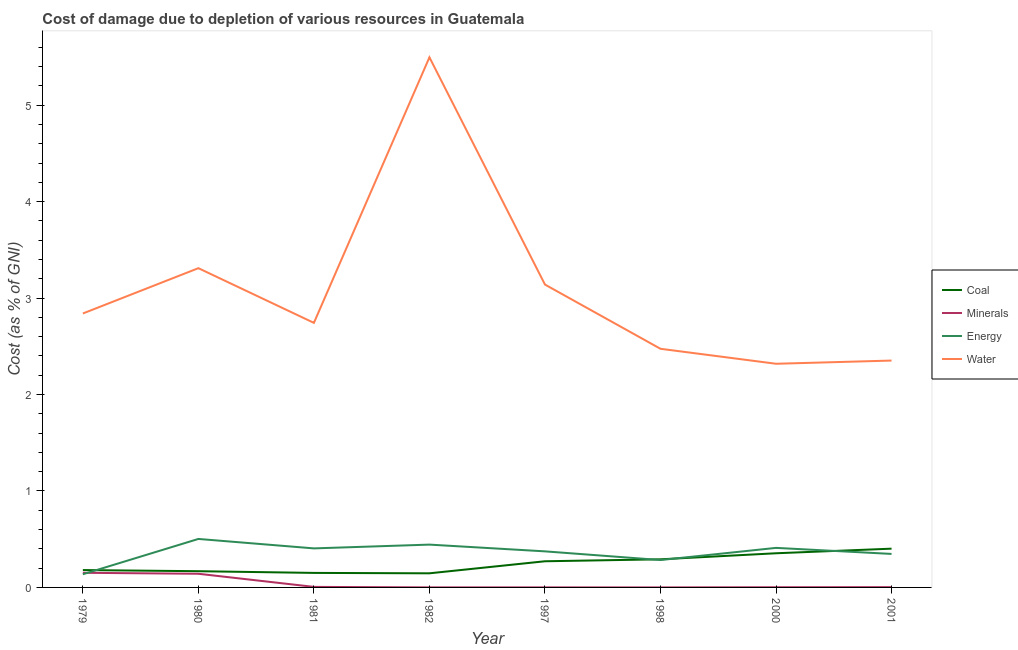How many different coloured lines are there?
Give a very brief answer. 4. Does the line corresponding to cost of damage due to depletion of coal intersect with the line corresponding to cost of damage due to depletion of minerals?
Offer a very short reply. No. Is the number of lines equal to the number of legend labels?
Your answer should be compact. Yes. What is the cost of damage due to depletion of water in 1981?
Provide a succinct answer. 2.74. Across all years, what is the maximum cost of damage due to depletion of minerals?
Provide a short and direct response. 0.15. Across all years, what is the minimum cost of damage due to depletion of water?
Make the answer very short. 2.32. In which year was the cost of damage due to depletion of energy maximum?
Your response must be concise. 1980. What is the total cost of damage due to depletion of minerals in the graph?
Your answer should be compact. 0.31. What is the difference between the cost of damage due to depletion of minerals in 1980 and that in 2001?
Your response must be concise. 0.14. What is the difference between the cost of damage due to depletion of water in 1997 and the cost of damage due to depletion of coal in 1998?
Keep it short and to the point. 2.85. What is the average cost of damage due to depletion of energy per year?
Offer a very short reply. 0.36. In the year 2000, what is the difference between the cost of damage due to depletion of energy and cost of damage due to depletion of water?
Offer a terse response. -1.91. What is the ratio of the cost of damage due to depletion of coal in 1979 to that in 2001?
Provide a short and direct response. 0.45. Is the cost of damage due to depletion of water in 1980 less than that in 2000?
Provide a short and direct response. No. Is the difference between the cost of damage due to depletion of water in 1981 and 2000 greater than the difference between the cost of damage due to depletion of coal in 1981 and 2000?
Your answer should be compact. Yes. What is the difference between the highest and the second highest cost of damage due to depletion of energy?
Provide a short and direct response. 0.06. What is the difference between the highest and the lowest cost of damage due to depletion of energy?
Your response must be concise. 0.37. Is the sum of the cost of damage due to depletion of coal in 1982 and 2001 greater than the maximum cost of damage due to depletion of energy across all years?
Ensure brevity in your answer.  Yes. Is it the case that in every year, the sum of the cost of damage due to depletion of energy and cost of damage due to depletion of minerals is greater than the sum of cost of damage due to depletion of coal and cost of damage due to depletion of water?
Your answer should be compact. No. Is it the case that in every year, the sum of the cost of damage due to depletion of coal and cost of damage due to depletion of minerals is greater than the cost of damage due to depletion of energy?
Give a very brief answer. No. Does the cost of damage due to depletion of coal monotonically increase over the years?
Keep it short and to the point. No. How many years are there in the graph?
Provide a short and direct response. 8. What is the difference between two consecutive major ticks on the Y-axis?
Give a very brief answer. 1. How are the legend labels stacked?
Provide a short and direct response. Vertical. What is the title of the graph?
Offer a terse response. Cost of damage due to depletion of various resources in Guatemala . What is the label or title of the Y-axis?
Offer a terse response. Cost (as % of GNI). What is the Cost (as % of GNI) in Coal in 1979?
Provide a succinct answer. 0.18. What is the Cost (as % of GNI) of Minerals in 1979?
Your answer should be compact. 0.15. What is the Cost (as % of GNI) of Energy in 1979?
Provide a short and direct response. 0.14. What is the Cost (as % of GNI) in Water in 1979?
Your answer should be compact. 2.84. What is the Cost (as % of GNI) in Coal in 1980?
Provide a short and direct response. 0.17. What is the Cost (as % of GNI) of Minerals in 1980?
Ensure brevity in your answer.  0.14. What is the Cost (as % of GNI) in Energy in 1980?
Your answer should be compact. 0.5. What is the Cost (as % of GNI) of Water in 1980?
Ensure brevity in your answer.  3.31. What is the Cost (as % of GNI) of Coal in 1981?
Offer a very short reply. 0.15. What is the Cost (as % of GNI) in Minerals in 1981?
Offer a very short reply. 0.01. What is the Cost (as % of GNI) of Energy in 1981?
Provide a short and direct response. 0.4. What is the Cost (as % of GNI) of Water in 1981?
Your response must be concise. 2.74. What is the Cost (as % of GNI) of Coal in 1982?
Give a very brief answer. 0.15. What is the Cost (as % of GNI) of Minerals in 1982?
Offer a very short reply. 0. What is the Cost (as % of GNI) of Energy in 1982?
Offer a terse response. 0.44. What is the Cost (as % of GNI) of Water in 1982?
Give a very brief answer. 5.5. What is the Cost (as % of GNI) of Coal in 1997?
Offer a very short reply. 0.27. What is the Cost (as % of GNI) in Minerals in 1997?
Make the answer very short. 0. What is the Cost (as % of GNI) of Energy in 1997?
Keep it short and to the point. 0.37. What is the Cost (as % of GNI) of Water in 1997?
Offer a very short reply. 3.14. What is the Cost (as % of GNI) in Coal in 1998?
Make the answer very short. 0.29. What is the Cost (as % of GNI) of Minerals in 1998?
Your response must be concise. 0. What is the Cost (as % of GNI) in Energy in 1998?
Offer a very short reply. 0.28. What is the Cost (as % of GNI) in Water in 1998?
Offer a terse response. 2.47. What is the Cost (as % of GNI) in Coal in 2000?
Provide a short and direct response. 0.35. What is the Cost (as % of GNI) in Minerals in 2000?
Keep it short and to the point. 0. What is the Cost (as % of GNI) in Energy in 2000?
Provide a succinct answer. 0.41. What is the Cost (as % of GNI) in Water in 2000?
Your answer should be very brief. 2.32. What is the Cost (as % of GNI) in Coal in 2001?
Give a very brief answer. 0.4. What is the Cost (as % of GNI) of Minerals in 2001?
Ensure brevity in your answer.  0. What is the Cost (as % of GNI) in Energy in 2001?
Provide a succinct answer. 0.35. What is the Cost (as % of GNI) in Water in 2001?
Provide a succinct answer. 2.35. Across all years, what is the maximum Cost (as % of GNI) of Coal?
Offer a terse response. 0.4. Across all years, what is the maximum Cost (as % of GNI) in Minerals?
Ensure brevity in your answer.  0.15. Across all years, what is the maximum Cost (as % of GNI) of Energy?
Provide a succinct answer. 0.5. Across all years, what is the maximum Cost (as % of GNI) of Water?
Your answer should be compact. 5.5. Across all years, what is the minimum Cost (as % of GNI) of Coal?
Offer a terse response. 0.15. Across all years, what is the minimum Cost (as % of GNI) in Minerals?
Keep it short and to the point. 0. Across all years, what is the minimum Cost (as % of GNI) of Energy?
Provide a short and direct response. 0.14. Across all years, what is the minimum Cost (as % of GNI) in Water?
Offer a terse response. 2.32. What is the total Cost (as % of GNI) of Coal in the graph?
Give a very brief answer. 1.96. What is the total Cost (as % of GNI) in Minerals in the graph?
Your answer should be very brief. 0.31. What is the total Cost (as % of GNI) of Energy in the graph?
Your answer should be compact. 2.9. What is the total Cost (as % of GNI) in Water in the graph?
Give a very brief answer. 24.68. What is the difference between the Cost (as % of GNI) in Coal in 1979 and that in 1980?
Provide a succinct answer. 0.01. What is the difference between the Cost (as % of GNI) of Minerals in 1979 and that in 1980?
Make the answer very short. 0.01. What is the difference between the Cost (as % of GNI) in Energy in 1979 and that in 1980?
Provide a succinct answer. -0.37. What is the difference between the Cost (as % of GNI) in Water in 1979 and that in 1980?
Offer a terse response. -0.47. What is the difference between the Cost (as % of GNI) in Coal in 1979 and that in 1981?
Make the answer very short. 0.03. What is the difference between the Cost (as % of GNI) of Minerals in 1979 and that in 1981?
Your answer should be very brief. 0.15. What is the difference between the Cost (as % of GNI) in Energy in 1979 and that in 1981?
Give a very brief answer. -0.27. What is the difference between the Cost (as % of GNI) of Water in 1979 and that in 1981?
Offer a terse response. 0.1. What is the difference between the Cost (as % of GNI) in Coal in 1979 and that in 1982?
Give a very brief answer. 0.03. What is the difference between the Cost (as % of GNI) in Minerals in 1979 and that in 1982?
Your response must be concise. 0.15. What is the difference between the Cost (as % of GNI) of Energy in 1979 and that in 1982?
Your answer should be compact. -0.31. What is the difference between the Cost (as % of GNI) in Water in 1979 and that in 1982?
Your answer should be very brief. -2.66. What is the difference between the Cost (as % of GNI) in Coal in 1979 and that in 1997?
Offer a very short reply. -0.09. What is the difference between the Cost (as % of GNI) of Minerals in 1979 and that in 1997?
Keep it short and to the point. 0.15. What is the difference between the Cost (as % of GNI) in Energy in 1979 and that in 1997?
Provide a short and direct response. -0.24. What is the difference between the Cost (as % of GNI) of Water in 1979 and that in 1997?
Give a very brief answer. -0.3. What is the difference between the Cost (as % of GNI) in Coal in 1979 and that in 1998?
Your answer should be very brief. -0.11. What is the difference between the Cost (as % of GNI) in Minerals in 1979 and that in 1998?
Keep it short and to the point. 0.15. What is the difference between the Cost (as % of GNI) of Energy in 1979 and that in 1998?
Your response must be concise. -0.15. What is the difference between the Cost (as % of GNI) of Water in 1979 and that in 1998?
Offer a terse response. 0.37. What is the difference between the Cost (as % of GNI) in Coal in 1979 and that in 2000?
Keep it short and to the point. -0.17. What is the difference between the Cost (as % of GNI) of Minerals in 1979 and that in 2000?
Your response must be concise. 0.15. What is the difference between the Cost (as % of GNI) in Energy in 1979 and that in 2000?
Make the answer very short. -0.27. What is the difference between the Cost (as % of GNI) of Water in 1979 and that in 2000?
Provide a short and direct response. 0.52. What is the difference between the Cost (as % of GNI) in Coal in 1979 and that in 2001?
Provide a short and direct response. -0.22. What is the difference between the Cost (as % of GNI) in Minerals in 1979 and that in 2001?
Ensure brevity in your answer.  0.15. What is the difference between the Cost (as % of GNI) in Energy in 1979 and that in 2001?
Your answer should be compact. -0.21. What is the difference between the Cost (as % of GNI) of Water in 1979 and that in 2001?
Your answer should be very brief. 0.49. What is the difference between the Cost (as % of GNI) in Coal in 1980 and that in 1981?
Ensure brevity in your answer.  0.02. What is the difference between the Cost (as % of GNI) of Minerals in 1980 and that in 1981?
Keep it short and to the point. 0.14. What is the difference between the Cost (as % of GNI) in Energy in 1980 and that in 1981?
Offer a very short reply. 0.1. What is the difference between the Cost (as % of GNI) of Water in 1980 and that in 1981?
Give a very brief answer. 0.57. What is the difference between the Cost (as % of GNI) in Coal in 1980 and that in 1982?
Your answer should be compact. 0.02. What is the difference between the Cost (as % of GNI) in Minerals in 1980 and that in 1982?
Your answer should be compact. 0.14. What is the difference between the Cost (as % of GNI) of Energy in 1980 and that in 1982?
Provide a succinct answer. 0.06. What is the difference between the Cost (as % of GNI) in Water in 1980 and that in 1982?
Ensure brevity in your answer.  -2.19. What is the difference between the Cost (as % of GNI) of Coal in 1980 and that in 1997?
Make the answer very short. -0.1. What is the difference between the Cost (as % of GNI) of Minerals in 1980 and that in 1997?
Offer a very short reply. 0.14. What is the difference between the Cost (as % of GNI) of Energy in 1980 and that in 1997?
Make the answer very short. 0.13. What is the difference between the Cost (as % of GNI) in Water in 1980 and that in 1997?
Keep it short and to the point. 0.17. What is the difference between the Cost (as % of GNI) of Coal in 1980 and that in 1998?
Provide a succinct answer. -0.12. What is the difference between the Cost (as % of GNI) in Minerals in 1980 and that in 1998?
Your answer should be very brief. 0.14. What is the difference between the Cost (as % of GNI) of Energy in 1980 and that in 1998?
Provide a succinct answer. 0.22. What is the difference between the Cost (as % of GNI) in Water in 1980 and that in 1998?
Ensure brevity in your answer.  0.84. What is the difference between the Cost (as % of GNI) in Coal in 1980 and that in 2000?
Your answer should be compact. -0.19. What is the difference between the Cost (as % of GNI) in Minerals in 1980 and that in 2000?
Keep it short and to the point. 0.14. What is the difference between the Cost (as % of GNI) in Energy in 1980 and that in 2000?
Make the answer very short. 0.09. What is the difference between the Cost (as % of GNI) in Water in 1980 and that in 2000?
Your response must be concise. 0.99. What is the difference between the Cost (as % of GNI) of Coal in 1980 and that in 2001?
Offer a terse response. -0.23. What is the difference between the Cost (as % of GNI) in Minerals in 1980 and that in 2001?
Provide a short and direct response. 0.14. What is the difference between the Cost (as % of GNI) of Energy in 1980 and that in 2001?
Your answer should be compact. 0.16. What is the difference between the Cost (as % of GNI) of Water in 1980 and that in 2001?
Give a very brief answer. 0.96. What is the difference between the Cost (as % of GNI) in Coal in 1981 and that in 1982?
Provide a short and direct response. 0. What is the difference between the Cost (as % of GNI) of Minerals in 1981 and that in 1982?
Provide a succinct answer. 0.01. What is the difference between the Cost (as % of GNI) of Energy in 1981 and that in 1982?
Offer a very short reply. -0.04. What is the difference between the Cost (as % of GNI) of Water in 1981 and that in 1982?
Your answer should be very brief. -2.75. What is the difference between the Cost (as % of GNI) in Coal in 1981 and that in 1997?
Provide a succinct answer. -0.12. What is the difference between the Cost (as % of GNI) of Minerals in 1981 and that in 1997?
Keep it short and to the point. 0.01. What is the difference between the Cost (as % of GNI) of Energy in 1981 and that in 1997?
Your answer should be very brief. 0.03. What is the difference between the Cost (as % of GNI) in Water in 1981 and that in 1997?
Make the answer very short. -0.4. What is the difference between the Cost (as % of GNI) in Coal in 1981 and that in 1998?
Give a very brief answer. -0.14. What is the difference between the Cost (as % of GNI) of Minerals in 1981 and that in 1998?
Ensure brevity in your answer.  0.01. What is the difference between the Cost (as % of GNI) in Energy in 1981 and that in 1998?
Keep it short and to the point. 0.12. What is the difference between the Cost (as % of GNI) of Water in 1981 and that in 1998?
Give a very brief answer. 0.27. What is the difference between the Cost (as % of GNI) of Coal in 1981 and that in 2000?
Offer a terse response. -0.2. What is the difference between the Cost (as % of GNI) in Minerals in 1981 and that in 2000?
Ensure brevity in your answer.  0. What is the difference between the Cost (as % of GNI) in Energy in 1981 and that in 2000?
Keep it short and to the point. -0.01. What is the difference between the Cost (as % of GNI) of Water in 1981 and that in 2000?
Provide a short and direct response. 0.42. What is the difference between the Cost (as % of GNI) of Coal in 1981 and that in 2001?
Your response must be concise. -0.25. What is the difference between the Cost (as % of GNI) of Minerals in 1981 and that in 2001?
Offer a terse response. 0. What is the difference between the Cost (as % of GNI) of Energy in 1981 and that in 2001?
Offer a very short reply. 0.06. What is the difference between the Cost (as % of GNI) in Water in 1981 and that in 2001?
Make the answer very short. 0.39. What is the difference between the Cost (as % of GNI) of Coal in 1982 and that in 1997?
Make the answer very short. -0.12. What is the difference between the Cost (as % of GNI) in Minerals in 1982 and that in 1997?
Ensure brevity in your answer.  0. What is the difference between the Cost (as % of GNI) in Energy in 1982 and that in 1997?
Your response must be concise. 0.07. What is the difference between the Cost (as % of GNI) in Water in 1982 and that in 1997?
Offer a terse response. 2.36. What is the difference between the Cost (as % of GNI) of Coal in 1982 and that in 1998?
Provide a succinct answer. -0.15. What is the difference between the Cost (as % of GNI) of Minerals in 1982 and that in 1998?
Your answer should be compact. 0. What is the difference between the Cost (as % of GNI) of Energy in 1982 and that in 1998?
Provide a succinct answer. 0.16. What is the difference between the Cost (as % of GNI) of Water in 1982 and that in 1998?
Provide a succinct answer. 3.02. What is the difference between the Cost (as % of GNI) of Coal in 1982 and that in 2000?
Make the answer very short. -0.21. What is the difference between the Cost (as % of GNI) in Minerals in 1982 and that in 2000?
Ensure brevity in your answer.  -0. What is the difference between the Cost (as % of GNI) of Energy in 1982 and that in 2000?
Provide a short and direct response. 0.03. What is the difference between the Cost (as % of GNI) in Water in 1982 and that in 2000?
Ensure brevity in your answer.  3.18. What is the difference between the Cost (as % of GNI) in Coal in 1982 and that in 2001?
Keep it short and to the point. -0.26. What is the difference between the Cost (as % of GNI) of Minerals in 1982 and that in 2001?
Provide a succinct answer. -0. What is the difference between the Cost (as % of GNI) in Energy in 1982 and that in 2001?
Your response must be concise. 0.1. What is the difference between the Cost (as % of GNI) of Water in 1982 and that in 2001?
Provide a short and direct response. 3.14. What is the difference between the Cost (as % of GNI) of Coal in 1997 and that in 1998?
Keep it short and to the point. -0.02. What is the difference between the Cost (as % of GNI) in Energy in 1997 and that in 1998?
Your response must be concise. 0.09. What is the difference between the Cost (as % of GNI) of Water in 1997 and that in 1998?
Your answer should be very brief. 0.67. What is the difference between the Cost (as % of GNI) in Coal in 1997 and that in 2000?
Offer a very short reply. -0.08. What is the difference between the Cost (as % of GNI) of Minerals in 1997 and that in 2000?
Keep it short and to the point. -0. What is the difference between the Cost (as % of GNI) of Energy in 1997 and that in 2000?
Ensure brevity in your answer.  -0.04. What is the difference between the Cost (as % of GNI) of Water in 1997 and that in 2000?
Provide a succinct answer. 0.82. What is the difference between the Cost (as % of GNI) of Coal in 1997 and that in 2001?
Your response must be concise. -0.13. What is the difference between the Cost (as % of GNI) in Minerals in 1997 and that in 2001?
Ensure brevity in your answer.  -0. What is the difference between the Cost (as % of GNI) in Energy in 1997 and that in 2001?
Provide a short and direct response. 0.03. What is the difference between the Cost (as % of GNI) in Water in 1997 and that in 2001?
Offer a terse response. 0.79. What is the difference between the Cost (as % of GNI) in Coal in 1998 and that in 2000?
Offer a terse response. -0.06. What is the difference between the Cost (as % of GNI) of Minerals in 1998 and that in 2000?
Provide a short and direct response. -0. What is the difference between the Cost (as % of GNI) in Energy in 1998 and that in 2000?
Your answer should be very brief. -0.13. What is the difference between the Cost (as % of GNI) in Water in 1998 and that in 2000?
Provide a succinct answer. 0.16. What is the difference between the Cost (as % of GNI) in Coal in 1998 and that in 2001?
Offer a very short reply. -0.11. What is the difference between the Cost (as % of GNI) in Minerals in 1998 and that in 2001?
Your answer should be very brief. -0. What is the difference between the Cost (as % of GNI) of Energy in 1998 and that in 2001?
Your answer should be compact. -0.06. What is the difference between the Cost (as % of GNI) of Water in 1998 and that in 2001?
Offer a terse response. 0.12. What is the difference between the Cost (as % of GNI) of Coal in 2000 and that in 2001?
Keep it short and to the point. -0.05. What is the difference between the Cost (as % of GNI) in Minerals in 2000 and that in 2001?
Keep it short and to the point. -0. What is the difference between the Cost (as % of GNI) of Energy in 2000 and that in 2001?
Offer a terse response. 0.06. What is the difference between the Cost (as % of GNI) of Water in 2000 and that in 2001?
Offer a terse response. -0.03. What is the difference between the Cost (as % of GNI) in Coal in 1979 and the Cost (as % of GNI) in Minerals in 1980?
Provide a succinct answer. 0.04. What is the difference between the Cost (as % of GNI) in Coal in 1979 and the Cost (as % of GNI) in Energy in 1980?
Your answer should be compact. -0.32. What is the difference between the Cost (as % of GNI) of Coal in 1979 and the Cost (as % of GNI) of Water in 1980?
Ensure brevity in your answer.  -3.13. What is the difference between the Cost (as % of GNI) of Minerals in 1979 and the Cost (as % of GNI) of Energy in 1980?
Provide a short and direct response. -0.35. What is the difference between the Cost (as % of GNI) of Minerals in 1979 and the Cost (as % of GNI) of Water in 1980?
Give a very brief answer. -3.16. What is the difference between the Cost (as % of GNI) of Energy in 1979 and the Cost (as % of GNI) of Water in 1980?
Offer a terse response. -3.17. What is the difference between the Cost (as % of GNI) in Coal in 1979 and the Cost (as % of GNI) in Minerals in 1981?
Your answer should be very brief. 0.17. What is the difference between the Cost (as % of GNI) of Coal in 1979 and the Cost (as % of GNI) of Energy in 1981?
Provide a succinct answer. -0.22. What is the difference between the Cost (as % of GNI) of Coal in 1979 and the Cost (as % of GNI) of Water in 1981?
Your response must be concise. -2.56. What is the difference between the Cost (as % of GNI) of Minerals in 1979 and the Cost (as % of GNI) of Energy in 1981?
Give a very brief answer. -0.25. What is the difference between the Cost (as % of GNI) of Minerals in 1979 and the Cost (as % of GNI) of Water in 1981?
Your response must be concise. -2.59. What is the difference between the Cost (as % of GNI) of Energy in 1979 and the Cost (as % of GNI) of Water in 1981?
Give a very brief answer. -2.61. What is the difference between the Cost (as % of GNI) in Coal in 1979 and the Cost (as % of GNI) in Minerals in 1982?
Offer a very short reply. 0.18. What is the difference between the Cost (as % of GNI) in Coal in 1979 and the Cost (as % of GNI) in Energy in 1982?
Give a very brief answer. -0.26. What is the difference between the Cost (as % of GNI) of Coal in 1979 and the Cost (as % of GNI) of Water in 1982?
Ensure brevity in your answer.  -5.32. What is the difference between the Cost (as % of GNI) of Minerals in 1979 and the Cost (as % of GNI) of Energy in 1982?
Provide a short and direct response. -0.29. What is the difference between the Cost (as % of GNI) in Minerals in 1979 and the Cost (as % of GNI) in Water in 1982?
Ensure brevity in your answer.  -5.34. What is the difference between the Cost (as % of GNI) of Energy in 1979 and the Cost (as % of GNI) of Water in 1982?
Provide a succinct answer. -5.36. What is the difference between the Cost (as % of GNI) of Coal in 1979 and the Cost (as % of GNI) of Minerals in 1997?
Provide a short and direct response. 0.18. What is the difference between the Cost (as % of GNI) in Coal in 1979 and the Cost (as % of GNI) in Energy in 1997?
Provide a succinct answer. -0.19. What is the difference between the Cost (as % of GNI) of Coal in 1979 and the Cost (as % of GNI) of Water in 1997?
Your response must be concise. -2.96. What is the difference between the Cost (as % of GNI) of Minerals in 1979 and the Cost (as % of GNI) of Energy in 1997?
Give a very brief answer. -0.22. What is the difference between the Cost (as % of GNI) of Minerals in 1979 and the Cost (as % of GNI) of Water in 1997?
Provide a succinct answer. -2.99. What is the difference between the Cost (as % of GNI) in Energy in 1979 and the Cost (as % of GNI) in Water in 1997?
Offer a terse response. -3. What is the difference between the Cost (as % of GNI) in Coal in 1979 and the Cost (as % of GNI) in Minerals in 1998?
Offer a very short reply. 0.18. What is the difference between the Cost (as % of GNI) of Coal in 1979 and the Cost (as % of GNI) of Energy in 1998?
Your answer should be compact. -0.1. What is the difference between the Cost (as % of GNI) in Coal in 1979 and the Cost (as % of GNI) in Water in 1998?
Offer a very short reply. -2.29. What is the difference between the Cost (as % of GNI) of Minerals in 1979 and the Cost (as % of GNI) of Energy in 1998?
Offer a very short reply. -0.13. What is the difference between the Cost (as % of GNI) of Minerals in 1979 and the Cost (as % of GNI) of Water in 1998?
Offer a terse response. -2.32. What is the difference between the Cost (as % of GNI) of Energy in 1979 and the Cost (as % of GNI) of Water in 1998?
Your answer should be very brief. -2.34. What is the difference between the Cost (as % of GNI) of Coal in 1979 and the Cost (as % of GNI) of Minerals in 2000?
Give a very brief answer. 0.18. What is the difference between the Cost (as % of GNI) of Coal in 1979 and the Cost (as % of GNI) of Energy in 2000?
Offer a terse response. -0.23. What is the difference between the Cost (as % of GNI) in Coal in 1979 and the Cost (as % of GNI) in Water in 2000?
Offer a terse response. -2.14. What is the difference between the Cost (as % of GNI) of Minerals in 1979 and the Cost (as % of GNI) of Energy in 2000?
Offer a terse response. -0.26. What is the difference between the Cost (as % of GNI) of Minerals in 1979 and the Cost (as % of GNI) of Water in 2000?
Your response must be concise. -2.17. What is the difference between the Cost (as % of GNI) of Energy in 1979 and the Cost (as % of GNI) of Water in 2000?
Make the answer very short. -2.18. What is the difference between the Cost (as % of GNI) in Coal in 1979 and the Cost (as % of GNI) in Minerals in 2001?
Your answer should be very brief. 0.18. What is the difference between the Cost (as % of GNI) in Coal in 1979 and the Cost (as % of GNI) in Energy in 2001?
Your response must be concise. -0.17. What is the difference between the Cost (as % of GNI) in Coal in 1979 and the Cost (as % of GNI) in Water in 2001?
Keep it short and to the point. -2.17. What is the difference between the Cost (as % of GNI) in Minerals in 1979 and the Cost (as % of GNI) in Energy in 2001?
Provide a short and direct response. -0.2. What is the difference between the Cost (as % of GNI) in Minerals in 1979 and the Cost (as % of GNI) in Water in 2001?
Offer a terse response. -2.2. What is the difference between the Cost (as % of GNI) of Energy in 1979 and the Cost (as % of GNI) of Water in 2001?
Your answer should be compact. -2.22. What is the difference between the Cost (as % of GNI) in Coal in 1980 and the Cost (as % of GNI) in Minerals in 1981?
Your response must be concise. 0.16. What is the difference between the Cost (as % of GNI) of Coal in 1980 and the Cost (as % of GNI) of Energy in 1981?
Make the answer very short. -0.24. What is the difference between the Cost (as % of GNI) in Coal in 1980 and the Cost (as % of GNI) in Water in 1981?
Provide a short and direct response. -2.58. What is the difference between the Cost (as % of GNI) in Minerals in 1980 and the Cost (as % of GNI) in Energy in 1981?
Provide a succinct answer. -0.26. What is the difference between the Cost (as % of GNI) of Minerals in 1980 and the Cost (as % of GNI) of Water in 1981?
Provide a succinct answer. -2.6. What is the difference between the Cost (as % of GNI) of Energy in 1980 and the Cost (as % of GNI) of Water in 1981?
Provide a short and direct response. -2.24. What is the difference between the Cost (as % of GNI) in Coal in 1980 and the Cost (as % of GNI) in Minerals in 1982?
Provide a short and direct response. 0.17. What is the difference between the Cost (as % of GNI) in Coal in 1980 and the Cost (as % of GNI) in Energy in 1982?
Your answer should be compact. -0.28. What is the difference between the Cost (as % of GNI) in Coal in 1980 and the Cost (as % of GNI) in Water in 1982?
Offer a terse response. -5.33. What is the difference between the Cost (as % of GNI) of Minerals in 1980 and the Cost (as % of GNI) of Energy in 1982?
Keep it short and to the point. -0.3. What is the difference between the Cost (as % of GNI) in Minerals in 1980 and the Cost (as % of GNI) in Water in 1982?
Ensure brevity in your answer.  -5.36. What is the difference between the Cost (as % of GNI) in Energy in 1980 and the Cost (as % of GNI) in Water in 1982?
Your answer should be compact. -4.99. What is the difference between the Cost (as % of GNI) in Coal in 1980 and the Cost (as % of GNI) in Minerals in 1997?
Ensure brevity in your answer.  0.17. What is the difference between the Cost (as % of GNI) in Coal in 1980 and the Cost (as % of GNI) in Energy in 1997?
Offer a terse response. -0.21. What is the difference between the Cost (as % of GNI) of Coal in 1980 and the Cost (as % of GNI) of Water in 1997?
Ensure brevity in your answer.  -2.97. What is the difference between the Cost (as % of GNI) in Minerals in 1980 and the Cost (as % of GNI) in Energy in 1997?
Provide a succinct answer. -0.23. What is the difference between the Cost (as % of GNI) of Minerals in 1980 and the Cost (as % of GNI) of Water in 1997?
Provide a short and direct response. -3. What is the difference between the Cost (as % of GNI) of Energy in 1980 and the Cost (as % of GNI) of Water in 1997?
Make the answer very short. -2.64. What is the difference between the Cost (as % of GNI) in Coal in 1980 and the Cost (as % of GNI) in Minerals in 1998?
Your answer should be very brief. 0.17. What is the difference between the Cost (as % of GNI) in Coal in 1980 and the Cost (as % of GNI) in Energy in 1998?
Ensure brevity in your answer.  -0.12. What is the difference between the Cost (as % of GNI) in Coal in 1980 and the Cost (as % of GNI) in Water in 1998?
Provide a succinct answer. -2.31. What is the difference between the Cost (as % of GNI) of Minerals in 1980 and the Cost (as % of GNI) of Energy in 1998?
Your answer should be compact. -0.14. What is the difference between the Cost (as % of GNI) in Minerals in 1980 and the Cost (as % of GNI) in Water in 1998?
Ensure brevity in your answer.  -2.33. What is the difference between the Cost (as % of GNI) in Energy in 1980 and the Cost (as % of GNI) in Water in 1998?
Your answer should be compact. -1.97. What is the difference between the Cost (as % of GNI) in Coal in 1980 and the Cost (as % of GNI) in Minerals in 2000?
Your answer should be compact. 0.17. What is the difference between the Cost (as % of GNI) in Coal in 1980 and the Cost (as % of GNI) in Energy in 2000?
Your response must be concise. -0.24. What is the difference between the Cost (as % of GNI) of Coal in 1980 and the Cost (as % of GNI) of Water in 2000?
Keep it short and to the point. -2.15. What is the difference between the Cost (as % of GNI) in Minerals in 1980 and the Cost (as % of GNI) in Energy in 2000?
Keep it short and to the point. -0.27. What is the difference between the Cost (as % of GNI) in Minerals in 1980 and the Cost (as % of GNI) in Water in 2000?
Provide a succinct answer. -2.18. What is the difference between the Cost (as % of GNI) of Energy in 1980 and the Cost (as % of GNI) of Water in 2000?
Your answer should be very brief. -1.82. What is the difference between the Cost (as % of GNI) of Coal in 1980 and the Cost (as % of GNI) of Minerals in 2001?
Ensure brevity in your answer.  0.17. What is the difference between the Cost (as % of GNI) in Coal in 1980 and the Cost (as % of GNI) in Energy in 2001?
Provide a succinct answer. -0.18. What is the difference between the Cost (as % of GNI) in Coal in 1980 and the Cost (as % of GNI) in Water in 2001?
Your answer should be compact. -2.18. What is the difference between the Cost (as % of GNI) of Minerals in 1980 and the Cost (as % of GNI) of Energy in 2001?
Provide a short and direct response. -0.21. What is the difference between the Cost (as % of GNI) in Minerals in 1980 and the Cost (as % of GNI) in Water in 2001?
Ensure brevity in your answer.  -2.21. What is the difference between the Cost (as % of GNI) in Energy in 1980 and the Cost (as % of GNI) in Water in 2001?
Offer a very short reply. -1.85. What is the difference between the Cost (as % of GNI) in Coal in 1981 and the Cost (as % of GNI) in Energy in 1982?
Provide a succinct answer. -0.29. What is the difference between the Cost (as % of GNI) in Coal in 1981 and the Cost (as % of GNI) in Water in 1982?
Make the answer very short. -5.35. What is the difference between the Cost (as % of GNI) in Minerals in 1981 and the Cost (as % of GNI) in Energy in 1982?
Make the answer very short. -0.44. What is the difference between the Cost (as % of GNI) in Minerals in 1981 and the Cost (as % of GNI) in Water in 1982?
Your response must be concise. -5.49. What is the difference between the Cost (as % of GNI) of Energy in 1981 and the Cost (as % of GNI) of Water in 1982?
Provide a succinct answer. -5.09. What is the difference between the Cost (as % of GNI) in Coal in 1981 and the Cost (as % of GNI) in Energy in 1997?
Your answer should be compact. -0.22. What is the difference between the Cost (as % of GNI) of Coal in 1981 and the Cost (as % of GNI) of Water in 1997?
Your answer should be compact. -2.99. What is the difference between the Cost (as % of GNI) of Minerals in 1981 and the Cost (as % of GNI) of Energy in 1997?
Your answer should be compact. -0.37. What is the difference between the Cost (as % of GNI) of Minerals in 1981 and the Cost (as % of GNI) of Water in 1997?
Your answer should be very brief. -3.13. What is the difference between the Cost (as % of GNI) of Energy in 1981 and the Cost (as % of GNI) of Water in 1997?
Offer a very short reply. -2.74. What is the difference between the Cost (as % of GNI) in Coal in 1981 and the Cost (as % of GNI) in Minerals in 1998?
Your answer should be very brief. 0.15. What is the difference between the Cost (as % of GNI) of Coal in 1981 and the Cost (as % of GNI) of Energy in 1998?
Your response must be concise. -0.13. What is the difference between the Cost (as % of GNI) of Coal in 1981 and the Cost (as % of GNI) of Water in 1998?
Offer a terse response. -2.32. What is the difference between the Cost (as % of GNI) in Minerals in 1981 and the Cost (as % of GNI) in Energy in 1998?
Ensure brevity in your answer.  -0.28. What is the difference between the Cost (as % of GNI) in Minerals in 1981 and the Cost (as % of GNI) in Water in 1998?
Your response must be concise. -2.47. What is the difference between the Cost (as % of GNI) in Energy in 1981 and the Cost (as % of GNI) in Water in 1998?
Offer a very short reply. -2.07. What is the difference between the Cost (as % of GNI) in Coal in 1981 and the Cost (as % of GNI) in Minerals in 2000?
Offer a terse response. 0.15. What is the difference between the Cost (as % of GNI) in Coal in 1981 and the Cost (as % of GNI) in Energy in 2000?
Ensure brevity in your answer.  -0.26. What is the difference between the Cost (as % of GNI) of Coal in 1981 and the Cost (as % of GNI) of Water in 2000?
Your answer should be compact. -2.17. What is the difference between the Cost (as % of GNI) of Minerals in 1981 and the Cost (as % of GNI) of Energy in 2000?
Give a very brief answer. -0.4. What is the difference between the Cost (as % of GNI) in Minerals in 1981 and the Cost (as % of GNI) in Water in 2000?
Your answer should be very brief. -2.31. What is the difference between the Cost (as % of GNI) of Energy in 1981 and the Cost (as % of GNI) of Water in 2000?
Your answer should be compact. -1.91. What is the difference between the Cost (as % of GNI) of Coal in 1981 and the Cost (as % of GNI) of Minerals in 2001?
Ensure brevity in your answer.  0.15. What is the difference between the Cost (as % of GNI) of Coal in 1981 and the Cost (as % of GNI) of Energy in 2001?
Offer a very short reply. -0.2. What is the difference between the Cost (as % of GNI) in Coal in 1981 and the Cost (as % of GNI) in Water in 2001?
Your response must be concise. -2.2. What is the difference between the Cost (as % of GNI) in Minerals in 1981 and the Cost (as % of GNI) in Energy in 2001?
Your answer should be very brief. -0.34. What is the difference between the Cost (as % of GNI) of Minerals in 1981 and the Cost (as % of GNI) of Water in 2001?
Keep it short and to the point. -2.35. What is the difference between the Cost (as % of GNI) in Energy in 1981 and the Cost (as % of GNI) in Water in 2001?
Make the answer very short. -1.95. What is the difference between the Cost (as % of GNI) of Coal in 1982 and the Cost (as % of GNI) of Minerals in 1997?
Your answer should be compact. 0.15. What is the difference between the Cost (as % of GNI) of Coal in 1982 and the Cost (as % of GNI) of Energy in 1997?
Give a very brief answer. -0.23. What is the difference between the Cost (as % of GNI) of Coal in 1982 and the Cost (as % of GNI) of Water in 1997?
Your answer should be compact. -2.99. What is the difference between the Cost (as % of GNI) of Minerals in 1982 and the Cost (as % of GNI) of Energy in 1997?
Keep it short and to the point. -0.37. What is the difference between the Cost (as % of GNI) of Minerals in 1982 and the Cost (as % of GNI) of Water in 1997?
Ensure brevity in your answer.  -3.14. What is the difference between the Cost (as % of GNI) of Energy in 1982 and the Cost (as % of GNI) of Water in 1997?
Your answer should be compact. -2.7. What is the difference between the Cost (as % of GNI) of Coal in 1982 and the Cost (as % of GNI) of Minerals in 1998?
Provide a short and direct response. 0.15. What is the difference between the Cost (as % of GNI) of Coal in 1982 and the Cost (as % of GNI) of Energy in 1998?
Ensure brevity in your answer.  -0.14. What is the difference between the Cost (as % of GNI) of Coal in 1982 and the Cost (as % of GNI) of Water in 1998?
Make the answer very short. -2.33. What is the difference between the Cost (as % of GNI) in Minerals in 1982 and the Cost (as % of GNI) in Energy in 1998?
Your response must be concise. -0.28. What is the difference between the Cost (as % of GNI) in Minerals in 1982 and the Cost (as % of GNI) in Water in 1998?
Offer a terse response. -2.47. What is the difference between the Cost (as % of GNI) of Energy in 1982 and the Cost (as % of GNI) of Water in 1998?
Give a very brief answer. -2.03. What is the difference between the Cost (as % of GNI) of Coal in 1982 and the Cost (as % of GNI) of Minerals in 2000?
Keep it short and to the point. 0.14. What is the difference between the Cost (as % of GNI) of Coal in 1982 and the Cost (as % of GNI) of Energy in 2000?
Offer a very short reply. -0.26. What is the difference between the Cost (as % of GNI) of Coal in 1982 and the Cost (as % of GNI) of Water in 2000?
Provide a short and direct response. -2.17. What is the difference between the Cost (as % of GNI) in Minerals in 1982 and the Cost (as % of GNI) in Energy in 2000?
Provide a succinct answer. -0.41. What is the difference between the Cost (as % of GNI) in Minerals in 1982 and the Cost (as % of GNI) in Water in 2000?
Offer a terse response. -2.32. What is the difference between the Cost (as % of GNI) of Energy in 1982 and the Cost (as % of GNI) of Water in 2000?
Your answer should be compact. -1.88. What is the difference between the Cost (as % of GNI) in Coal in 1982 and the Cost (as % of GNI) in Minerals in 2001?
Provide a short and direct response. 0.14. What is the difference between the Cost (as % of GNI) of Coal in 1982 and the Cost (as % of GNI) of Energy in 2001?
Your answer should be compact. -0.2. What is the difference between the Cost (as % of GNI) in Coal in 1982 and the Cost (as % of GNI) in Water in 2001?
Your response must be concise. -2.21. What is the difference between the Cost (as % of GNI) in Minerals in 1982 and the Cost (as % of GNI) in Energy in 2001?
Make the answer very short. -0.35. What is the difference between the Cost (as % of GNI) in Minerals in 1982 and the Cost (as % of GNI) in Water in 2001?
Provide a succinct answer. -2.35. What is the difference between the Cost (as % of GNI) in Energy in 1982 and the Cost (as % of GNI) in Water in 2001?
Give a very brief answer. -1.91. What is the difference between the Cost (as % of GNI) in Coal in 1997 and the Cost (as % of GNI) in Minerals in 1998?
Your answer should be compact. 0.27. What is the difference between the Cost (as % of GNI) of Coal in 1997 and the Cost (as % of GNI) of Energy in 1998?
Ensure brevity in your answer.  -0.01. What is the difference between the Cost (as % of GNI) in Coal in 1997 and the Cost (as % of GNI) in Water in 1998?
Your response must be concise. -2.2. What is the difference between the Cost (as % of GNI) in Minerals in 1997 and the Cost (as % of GNI) in Energy in 1998?
Give a very brief answer. -0.28. What is the difference between the Cost (as % of GNI) in Minerals in 1997 and the Cost (as % of GNI) in Water in 1998?
Make the answer very short. -2.47. What is the difference between the Cost (as % of GNI) in Energy in 1997 and the Cost (as % of GNI) in Water in 1998?
Make the answer very short. -2.1. What is the difference between the Cost (as % of GNI) of Coal in 1997 and the Cost (as % of GNI) of Minerals in 2000?
Give a very brief answer. 0.27. What is the difference between the Cost (as % of GNI) of Coal in 1997 and the Cost (as % of GNI) of Energy in 2000?
Your answer should be very brief. -0.14. What is the difference between the Cost (as % of GNI) of Coal in 1997 and the Cost (as % of GNI) of Water in 2000?
Offer a terse response. -2.05. What is the difference between the Cost (as % of GNI) in Minerals in 1997 and the Cost (as % of GNI) in Energy in 2000?
Ensure brevity in your answer.  -0.41. What is the difference between the Cost (as % of GNI) of Minerals in 1997 and the Cost (as % of GNI) of Water in 2000?
Provide a short and direct response. -2.32. What is the difference between the Cost (as % of GNI) in Energy in 1997 and the Cost (as % of GNI) in Water in 2000?
Give a very brief answer. -1.95. What is the difference between the Cost (as % of GNI) in Coal in 1997 and the Cost (as % of GNI) in Minerals in 2001?
Your answer should be very brief. 0.27. What is the difference between the Cost (as % of GNI) in Coal in 1997 and the Cost (as % of GNI) in Energy in 2001?
Ensure brevity in your answer.  -0.08. What is the difference between the Cost (as % of GNI) in Coal in 1997 and the Cost (as % of GNI) in Water in 2001?
Offer a terse response. -2.08. What is the difference between the Cost (as % of GNI) of Minerals in 1997 and the Cost (as % of GNI) of Energy in 2001?
Keep it short and to the point. -0.35. What is the difference between the Cost (as % of GNI) in Minerals in 1997 and the Cost (as % of GNI) in Water in 2001?
Your answer should be very brief. -2.35. What is the difference between the Cost (as % of GNI) in Energy in 1997 and the Cost (as % of GNI) in Water in 2001?
Make the answer very short. -1.98. What is the difference between the Cost (as % of GNI) of Coal in 1998 and the Cost (as % of GNI) of Minerals in 2000?
Provide a succinct answer. 0.29. What is the difference between the Cost (as % of GNI) of Coal in 1998 and the Cost (as % of GNI) of Energy in 2000?
Make the answer very short. -0.12. What is the difference between the Cost (as % of GNI) in Coal in 1998 and the Cost (as % of GNI) in Water in 2000?
Offer a terse response. -2.03. What is the difference between the Cost (as % of GNI) in Minerals in 1998 and the Cost (as % of GNI) in Energy in 2000?
Offer a very short reply. -0.41. What is the difference between the Cost (as % of GNI) of Minerals in 1998 and the Cost (as % of GNI) of Water in 2000?
Offer a very short reply. -2.32. What is the difference between the Cost (as % of GNI) of Energy in 1998 and the Cost (as % of GNI) of Water in 2000?
Your answer should be very brief. -2.04. What is the difference between the Cost (as % of GNI) of Coal in 1998 and the Cost (as % of GNI) of Minerals in 2001?
Keep it short and to the point. 0.29. What is the difference between the Cost (as % of GNI) of Coal in 1998 and the Cost (as % of GNI) of Energy in 2001?
Ensure brevity in your answer.  -0.06. What is the difference between the Cost (as % of GNI) of Coal in 1998 and the Cost (as % of GNI) of Water in 2001?
Provide a succinct answer. -2.06. What is the difference between the Cost (as % of GNI) in Minerals in 1998 and the Cost (as % of GNI) in Energy in 2001?
Offer a terse response. -0.35. What is the difference between the Cost (as % of GNI) in Minerals in 1998 and the Cost (as % of GNI) in Water in 2001?
Offer a very short reply. -2.35. What is the difference between the Cost (as % of GNI) in Energy in 1998 and the Cost (as % of GNI) in Water in 2001?
Give a very brief answer. -2.07. What is the difference between the Cost (as % of GNI) of Coal in 2000 and the Cost (as % of GNI) of Minerals in 2001?
Keep it short and to the point. 0.35. What is the difference between the Cost (as % of GNI) of Coal in 2000 and the Cost (as % of GNI) of Energy in 2001?
Your response must be concise. 0.01. What is the difference between the Cost (as % of GNI) of Coal in 2000 and the Cost (as % of GNI) of Water in 2001?
Keep it short and to the point. -2. What is the difference between the Cost (as % of GNI) of Minerals in 2000 and the Cost (as % of GNI) of Energy in 2001?
Your response must be concise. -0.35. What is the difference between the Cost (as % of GNI) of Minerals in 2000 and the Cost (as % of GNI) of Water in 2001?
Keep it short and to the point. -2.35. What is the difference between the Cost (as % of GNI) in Energy in 2000 and the Cost (as % of GNI) in Water in 2001?
Give a very brief answer. -1.94. What is the average Cost (as % of GNI) in Coal per year?
Make the answer very short. 0.25. What is the average Cost (as % of GNI) of Minerals per year?
Your answer should be very brief. 0.04. What is the average Cost (as % of GNI) in Energy per year?
Make the answer very short. 0.36. What is the average Cost (as % of GNI) in Water per year?
Your answer should be compact. 3.08. In the year 1979, what is the difference between the Cost (as % of GNI) in Coal and Cost (as % of GNI) in Minerals?
Your answer should be compact. 0.03. In the year 1979, what is the difference between the Cost (as % of GNI) in Coal and Cost (as % of GNI) in Energy?
Provide a short and direct response. 0.04. In the year 1979, what is the difference between the Cost (as % of GNI) in Coal and Cost (as % of GNI) in Water?
Your response must be concise. -2.66. In the year 1979, what is the difference between the Cost (as % of GNI) of Minerals and Cost (as % of GNI) of Energy?
Make the answer very short. 0.02. In the year 1979, what is the difference between the Cost (as % of GNI) in Minerals and Cost (as % of GNI) in Water?
Your response must be concise. -2.69. In the year 1979, what is the difference between the Cost (as % of GNI) of Energy and Cost (as % of GNI) of Water?
Your response must be concise. -2.7. In the year 1980, what is the difference between the Cost (as % of GNI) in Coal and Cost (as % of GNI) in Minerals?
Offer a very short reply. 0.03. In the year 1980, what is the difference between the Cost (as % of GNI) of Coal and Cost (as % of GNI) of Energy?
Your answer should be very brief. -0.33. In the year 1980, what is the difference between the Cost (as % of GNI) in Coal and Cost (as % of GNI) in Water?
Your answer should be compact. -3.14. In the year 1980, what is the difference between the Cost (as % of GNI) in Minerals and Cost (as % of GNI) in Energy?
Make the answer very short. -0.36. In the year 1980, what is the difference between the Cost (as % of GNI) of Minerals and Cost (as % of GNI) of Water?
Provide a short and direct response. -3.17. In the year 1980, what is the difference between the Cost (as % of GNI) in Energy and Cost (as % of GNI) in Water?
Ensure brevity in your answer.  -2.81. In the year 1981, what is the difference between the Cost (as % of GNI) in Coal and Cost (as % of GNI) in Minerals?
Offer a terse response. 0.14. In the year 1981, what is the difference between the Cost (as % of GNI) of Coal and Cost (as % of GNI) of Energy?
Your answer should be compact. -0.25. In the year 1981, what is the difference between the Cost (as % of GNI) in Coal and Cost (as % of GNI) in Water?
Ensure brevity in your answer.  -2.59. In the year 1981, what is the difference between the Cost (as % of GNI) of Minerals and Cost (as % of GNI) of Energy?
Your answer should be compact. -0.4. In the year 1981, what is the difference between the Cost (as % of GNI) of Minerals and Cost (as % of GNI) of Water?
Your answer should be very brief. -2.74. In the year 1981, what is the difference between the Cost (as % of GNI) of Energy and Cost (as % of GNI) of Water?
Your response must be concise. -2.34. In the year 1982, what is the difference between the Cost (as % of GNI) of Coal and Cost (as % of GNI) of Minerals?
Offer a very short reply. 0.15. In the year 1982, what is the difference between the Cost (as % of GNI) of Coal and Cost (as % of GNI) of Energy?
Provide a short and direct response. -0.3. In the year 1982, what is the difference between the Cost (as % of GNI) of Coal and Cost (as % of GNI) of Water?
Offer a terse response. -5.35. In the year 1982, what is the difference between the Cost (as % of GNI) in Minerals and Cost (as % of GNI) in Energy?
Make the answer very short. -0.44. In the year 1982, what is the difference between the Cost (as % of GNI) in Minerals and Cost (as % of GNI) in Water?
Make the answer very short. -5.5. In the year 1982, what is the difference between the Cost (as % of GNI) of Energy and Cost (as % of GNI) of Water?
Make the answer very short. -5.05. In the year 1997, what is the difference between the Cost (as % of GNI) of Coal and Cost (as % of GNI) of Minerals?
Offer a terse response. 0.27. In the year 1997, what is the difference between the Cost (as % of GNI) in Coal and Cost (as % of GNI) in Energy?
Your answer should be compact. -0.1. In the year 1997, what is the difference between the Cost (as % of GNI) of Coal and Cost (as % of GNI) of Water?
Keep it short and to the point. -2.87. In the year 1997, what is the difference between the Cost (as % of GNI) of Minerals and Cost (as % of GNI) of Energy?
Your response must be concise. -0.37. In the year 1997, what is the difference between the Cost (as % of GNI) of Minerals and Cost (as % of GNI) of Water?
Your answer should be compact. -3.14. In the year 1997, what is the difference between the Cost (as % of GNI) in Energy and Cost (as % of GNI) in Water?
Keep it short and to the point. -2.77. In the year 1998, what is the difference between the Cost (as % of GNI) of Coal and Cost (as % of GNI) of Minerals?
Provide a short and direct response. 0.29. In the year 1998, what is the difference between the Cost (as % of GNI) in Coal and Cost (as % of GNI) in Energy?
Provide a short and direct response. 0.01. In the year 1998, what is the difference between the Cost (as % of GNI) of Coal and Cost (as % of GNI) of Water?
Offer a terse response. -2.18. In the year 1998, what is the difference between the Cost (as % of GNI) in Minerals and Cost (as % of GNI) in Energy?
Offer a very short reply. -0.28. In the year 1998, what is the difference between the Cost (as % of GNI) in Minerals and Cost (as % of GNI) in Water?
Offer a terse response. -2.47. In the year 1998, what is the difference between the Cost (as % of GNI) of Energy and Cost (as % of GNI) of Water?
Provide a succinct answer. -2.19. In the year 2000, what is the difference between the Cost (as % of GNI) of Coal and Cost (as % of GNI) of Minerals?
Give a very brief answer. 0.35. In the year 2000, what is the difference between the Cost (as % of GNI) of Coal and Cost (as % of GNI) of Energy?
Make the answer very short. -0.06. In the year 2000, what is the difference between the Cost (as % of GNI) in Coal and Cost (as % of GNI) in Water?
Give a very brief answer. -1.97. In the year 2000, what is the difference between the Cost (as % of GNI) in Minerals and Cost (as % of GNI) in Energy?
Make the answer very short. -0.41. In the year 2000, what is the difference between the Cost (as % of GNI) of Minerals and Cost (as % of GNI) of Water?
Your answer should be very brief. -2.32. In the year 2000, what is the difference between the Cost (as % of GNI) of Energy and Cost (as % of GNI) of Water?
Your response must be concise. -1.91. In the year 2001, what is the difference between the Cost (as % of GNI) in Coal and Cost (as % of GNI) in Minerals?
Provide a short and direct response. 0.4. In the year 2001, what is the difference between the Cost (as % of GNI) in Coal and Cost (as % of GNI) in Energy?
Keep it short and to the point. 0.05. In the year 2001, what is the difference between the Cost (as % of GNI) of Coal and Cost (as % of GNI) of Water?
Make the answer very short. -1.95. In the year 2001, what is the difference between the Cost (as % of GNI) of Minerals and Cost (as % of GNI) of Energy?
Your response must be concise. -0.34. In the year 2001, what is the difference between the Cost (as % of GNI) in Minerals and Cost (as % of GNI) in Water?
Provide a succinct answer. -2.35. In the year 2001, what is the difference between the Cost (as % of GNI) in Energy and Cost (as % of GNI) in Water?
Ensure brevity in your answer.  -2. What is the ratio of the Cost (as % of GNI) in Coal in 1979 to that in 1980?
Provide a succinct answer. 1.07. What is the ratio of the Cost (as % of GNI) of Minerals in 1979 to that in 1980?
Offer a very short reply. 1.07. What is the ratio of the Cost (as % of GNI) in Energy in 1979 to that in 1980?
Ensure brevity in your answer.  0.27. What is the ratio of the Cost (as % of GNI) of Water in 1979 to that in 1980?
Offer a terse response. 0.86. What is the ratio of the Cost (as % of GNI) in Coal in 1979 to that in 1981?
Give a very brief answer. 1.2. What is the ratio of the Cost (as % of GNI) of Minerals in 1979 to that in 1981?
Make the answer very short. 27.3. What is the ratio of the Cost (as % of GNI) of Energy in 1979 to that in 1981?
Ensure brevity in your answer.  0.34. What is the ratio of the Cost (as % of GNI) of Water in 1979 to that in 1981?
Offer a terse response. 1.04. What is the ratio of the Cost (as % of GNI) of Coal in 1979 to that in 1982?
Make the answer very short. 1.23. What is the ratio of the Cost (as % of GNI) of Minerals in 1979 to that in 1982?
Ensure brevity in your answer.  280.48. What is the ratio of the Cost (as % of GNI) in Energy in 1979 to that in 1982?
Provide a succinct answer. 0.31. What is the ratio of the Cost (as % of GNI) of Water in 1979 to that in 1982?
Make the answer very short. 0.52. What is the ratio of the Cost (as % of GNI) of Coal in 1979 to that in 1997?
Your answer should be very brief. 0.66. What is the ratio of the Cost (as % of GNI) in Minerals in 1979 to that in 1997?
Keep it short and to the point. 318.88. What is the ratio of the Cost (as % of GNI) in Energy in 1979 to that in 1997?
Your answer should be very brief. 0.37. What is the ratio of the Cost (as % of GNI) of Water in 1979 to that in 1997?
Ensure brevity in your answer.  0.9. What is the ratio of the Cost (as % of GNI) in Coal in 1979 to that in 1998?
Make the answer very short. 0.62. What is the ratio of the Cost (as % of GNI) in Minerals in 1979 to that in 1998?
Your answer should be very brief. 949.07. What is the ratio of the Cost (as % of GNI) of Energy in 1979 to that in 1998?
Your answer should be compact. 0.48. What is the ratio of the Cost (as % of GNI) in Water in 1979 to that in 1998?
Provide a succinct answer. 1.15. What is the ratio of the Cost (as % of GNI) in Coal in 1979 to that in 2000?
Keep it short and to the point. 0.51. What is the ratio of the Cost (as % of GNI) of Minerals in 1979 to that in 2000?
Ensure brevity in your answer.  76.4. What is the ratio of the Cost (as % of GNI) of Energy in 1979 to that in 2000?
Offer a very short reply. 0.33. What is the ratio of the Cost (as % of GNI) of Water in 1979 to that in 2000?
Make the answer very short. 1.22. What is the ratio of the Cost (as % of GNI) in Coal in 1979 to that in 2001?
Make the answer very short. 0.45. What is the ratio of the Cost (as % of GNI) of Minerals in 1979 to that in 2001?
Make the answer very short. 47.54. What is the ratio of the Cost (as % of GNI) of Energy in 1979 to that in 2001?
Make the answer very short. 0.39. What is the ratio of the Cost (as % of GNI) of Water in 1979 to that in 2001?
Ensure brevity in your answer.  1.21. What is the ratio of the Cost (as % of GNI) of Coal in 1980 to that in 1981?
Your response must be concise. 1.12. What is the ratio of the Cost (as % of GNI) of Minerals in 1980 to that in 1981?
Your response must be concise. 25.48. What is the ratio of the Cost (as % of GNI) in Energy in 1980 to that in 1981?
Offer a very short reply. 1.24. What is the ratio of the Cost (as % of GNI) in Water in 1980 to that in 1981?
Offer a very short reply. 1.21. What is the ratio of the Cost (as % of GNI) of Coal in 1980 to that in 1982?
Keep it short and to the point. 1.15. What is the ratio of the Cost (as % of GNI) in Minerals in 1980 to that in 1982?
Your response must be concise. 261.78. What is the ratio of the Cost (as % of GNI) of Energy in 1980 to that in 1982?
Your answer should be compact. 1.13. What is the ratio of the Cost (as % of GNI) of Water in 1980 to that in 1982?
Give a very brief answer. 0.6. What is the ratio of the Cost (as % of GNI) in Coal in 1980 to that in 1997?
Offer a terse response. 0.62. What is the ratio of the Cost (as % of GNI) in Minerals in 1980 to that in 1997?
Give a very brief answer. 297.62. What is the ratio of the Cost (as % of GNI) of Energy in 1980 to that in 1997?
Provide a succinct answer. 1.34. What is the ratio of the Cost (as % of GNI) of Water in 1980 to that in 1997?
Your response must be concise. 1.05. What is the ratio of the Cost (as % of GNI) in Coal in 1980 to that in 1998?
Provide a short and direct response. 0.58. What is the ratio of the Cost (as % of GNI) of Minerals in 1980 to that in 1998?
Offer a terse response. 885.78. What is the ratio of the Cost (as % of GNI) in Energy in 1980 to that in 1998?
Your answer should be very brief. 1.77. What is the ratio of the Cost (as % of GNI) in Water in 1980 to that in 1998?
Your response must be concise. 1.34. What is the ratio of the Cost (as % of GNI) in Coal in 1980 to that in 2000?
Your response must be concise. 0.47. What is the ratio of the Cost (as % of GNI) of Minerals in 1980 to that in 2000?
Your answer should be very brief. 71.31. What is the ratio of the Cost (as % of GNI) of Energy in 1980 to that in 2000?
Ensure brevity in your answer.  1.23. What is the ratio of the Cost (as % of GNI) in Water in 1980 to that in 2000?
Offer a terse response. 1.43. What is the ratio of the Cost (as % of GNI) of Coal in 1980 to that in 2001?
Give a very brief answer. 0.42. What is the ratio of the Cost (as % of GNI) in Minerals in 1980 to that in 2001?
Offer a terse response. 44.37. What is the ratio of the Cost (as % of GNI) in Energy in 1980 to that in 2001?
Provide a short and direct response. 1.45. What is the ratio of the Cost (as % of GNI) in Water in 1980 to that in 2001?
Make the answer very short. 1.41. What is the ratio of the Cost (as % of GNI) of Coal in 1981 to that in 1982?
Your answer should be very brief. 1.03. What is the ratio of the Cost (as % of GNI) of Minerals in 1981 to that in 1982?
Offer a very short reply. 10.27. What is the ratio of the Cost (as % of GNI) in Energy in 1981 to that in 1982?
Give a very brief answer. 0.91. What is the ratio of the Cost (as % of GNI) in Water in 1981 to that in 1982?
Your answer should be compact. 0.5. What is the ratio of the Cost (as % of GNI) of Coal in 1981 to that in 1997?
Keep it short and to the point. 0.55. What is the ratio of the Cost (as % of GNI) in Minerals in 1981 to that in 1997?
Offer a very short reply. 11.68. What is the ratio of the Cost (as % of GNI) in Energy in 1981 to that in 1997?
Offer a very short reply. 1.08. What is the ratio of the Cost (as % of GNI) of Water in 1981 to that in 1997?
Provide a succinct answer. 0.87. What is the ratio of the Cost (as % of GNI) of Coal in 1981 to that in 1998?
Ensure brevity in your answer.  0.52. What is the ratio of the Cost (as % of GNI) in Minerals in 1981 to that in 1998?
Offer a terse response. 34.76. What is the ratio of the Cost (as % of GNI) of Energy in 1981 to that in 1998?
Make the answer very short. 1.42. What is the ratio of the Cost (as % of GNI) of Water in 1981 to that in 1998?
Offer a terse response. 1.11. What is the ratio of the Cost (as % of GNI) of Coal in 1981 to that in 2000?
Your response must be concise. 0.42. What is the ratio of the Cost (as % of GNI) in Minerals in 1981 to that in 2000?
Provide a short and direct response. 2.8. What is the ratio of the Cost (as % of GNI) in Energy in 1981 to that in 2000?
Provide a short and direct response. 0.99. What is the ratio of the Cost (as % of GNI) of Water in 1981 to that in 2000?
Your answer should be very brief. 1.18. What is the ratio of the Cost (as % of GNI) in Coal in 1981 to that in 2001?
Make the answer very short. 0.37. What is the ratio of the Cost (as % of GNI) in Minerals in 1981 to that in 2001?
Your answer should be very brief. 1.74. What is the ratio of the Cost (as % of GNI) of Energy in 1981 to that in 2001?
Give a very brief answer. 1.17. What is the ratio of the Cost (as % of GNI) in Water in 1981 to that in 2001?
Your answer should be very brief. 1.17. What is the ratio of the Cost (as % of GNI) of Coal in 1982 to that in 1997?
Provide a short and direct response. 0.54. What is the ratio of the Cost (as % of GNI) of Minerals in 1982 to that in 1997?
Keep it short and to the point. 1.14. What is the ratio of the Cost (as % of GNI) of Energy in 1982 to that in 1997?
Keep it short and to the point. 1.19. What is the ratio of the Cost (as % of GNI) in Water in 1982 to that in 1997?
Your answer should be very brief. 1.75. What is the ratio of the Cost (as % of GNI) of Coal in 1982 to that in 1998?
Make the answer very short. 0.5. What is the ratio of the Cost (as % of GNI) in Minerals in 1982 to that in 1998?
Provide a succinct answer. 3.38. What is the ratio of the Cost (as % of GNI) of Energy in 1982 to that in 1998?
Make the answer very short. 1.56. What is the ratio of the Cost (as % of GNI) in Water in 1982 to that in 1998?
Keep it short and to the point. 2.22. What is the ratio of the Cost (as % of GNI) of Coal in 1982 to that in 2000?
Provide a short and direct response. 0.41. What is the ratio of the Cost (as % of GNI) of Minerals in 1982 to that in 2000?
Make the answer very short. 0.27. What is the ratio of the Cost (as % of GNI) in Energy in 1982 to that in 2000?
Make the answer very short. 1.08. What is the ratio of the Cost (as % of GNI) in Water in 1982 to that in 2000?
Your answer should be very brief. 2.37. What is the ratio of the Cost (as % of GNI) in Coal in 1982 to that in 2001?
Your answer should be very brief. 0.36. What is the ratio of the Cost (as % of GNI) in Minerals in 1982 to that in 2001?
Keep it short and to the point. 0.17. What is the ratio of the Cost (as % of GNI) of Energy in 1982 to that in 2001?
Provide a short and direct response. 1.28. What is the ratio of the Cost (as % of GNI) of Water in 1982 to that in 2001?
Offer a terse response. 2.34. What is the ratio of the Cost (as % of GNI) in Coal in 1997 to that in 1998?
Your response must be concise. 0.93. What is the ratio of the Cost (as % of GNI) of Minerals in 1997 to that in 1998?
Keep it short and to the point. 2.98. What is the ratio of the Cost (as % of GNI) in Energy in 1997 to that in 1998?
Offer a very short reply. 1.32. What is the ratio of the Cost (as % of GNI) in Water in 1997 to that in 1998?
Offer a very short reply. 1.27. What is the ratio of the Cost (as % of GNI) in Coal in 1997 to that in 2000?
Give a very brief answer. 0.77. What is the ratio of the Cost (as % of GNI) in Minerals in 1997 to that in 2000?
Keep it short and to the point. 0.24. What is the ratio of the Cost (as % of GNI) of Energy in 1997 to that in 2000?
Give a very brief answer. 0.91. What is the ratio of the Cost (as % of GNI) of Water in 1997 to that in 2000?
Your answer should be very brief. 1.35. What is the ratio of the Cost (as % of GNI) in Coal in 1997 to that in 2001?
Give a very brief answer. 0.67. What is the ratio of the Cost (as % of GNI) of Minerals in 1997 to that in 2001?
Give a very brief answer. 0.15. What is the ratio of the Cost (as % of GNI) in Energy in 1997 to that in 2001?
Keep it short and to the point. 1.08. What is the ratio of the Cost (as % of GNI) in Water in 1997 to that in 2001?
Your answer should be very brief. 1.33. What is the ratio of the Cost (as % of GNI) in Coal in 1998 to that in 2000?
Ensure brevity in your answer.  0.82. What is the ratio of the Cost (as % of GNI) of Minerals in 1998 to that in 2000?
Offer a terse response. 0.08. What is the ratio of the Cost (as % of GNI) in Energy in 1998 to that in 2000?
Your answer should be compact. 0.69. What is the ratio of the Cost (as % of GNI) in Water in 1998 to that in 2000?
Offer a terse response. 1.07. What is the ratio of the Cost (as % of GNI) of Coal in 1998 to that in 2001?
Give a very brief answer. 0.73. What is the ratio of the Cost (as % of GNI) of Minerals in 1998 to that in 2001?
Offer a very short reply. 0.05. What is the ratio of the Cost (as % of GNI) of Energy in 1998 to that in 2001?
Offer a terse response. 0.82. What is the ratio of the Cost (as % of GNI) in Water in 1998 to that in 2001?
Your answer should be compact. 1.05. What is the ratio of the Cost (as % of GNI) of Coal in 2000 to that in 2001?
Your response must be concise. 0.88. What is the ratio of the Cost (as % of GNI) in Minerals in 2000 to that in 2001?
Offer a very short reply. 0.62. What is the ratio of the Cost (as % of GNI) of Energy in 2000 to that in 2001?
Your answer should be very brief. 1.18. What is the ratio of the Cost (as % of GNI) in Water in 2000 to that in 2001?
Offer a very short reply. 0.99. What is the difference between the highest and the second highest Cost (as % of GNI) of Coal?
Your answer should be very brief. 0.05. What is the difference between the highest and the second highest Cost (as % of GNI) in Minerals?
Ensure brevity in your answer.  0.01. What is the difference between the highest and the second highest Cost (as % of GNI) of Energy?
Give a very brief answer. 0.06. What is the difference between the highest and the second highest Cost (as % of GNI) of Water?
Provide a short and direct response. 2.19. What is the difference between the highest and the lowest Cost (as % of GNI) of Coal?
Give a very brief answer. 0.26. What is the difference between the highest and the lowest Cost (as % of GNI) in Minerals?
Make the answer very short. 0.15. What is the difference between the highest and the lowest Cost (as % of GNI) in Energy?
Your answer should be very brief. 0.37. What is the difference between the highest and the lowest Cost (as % of GNI) in Water?
Make the answer very short. 3.18. 